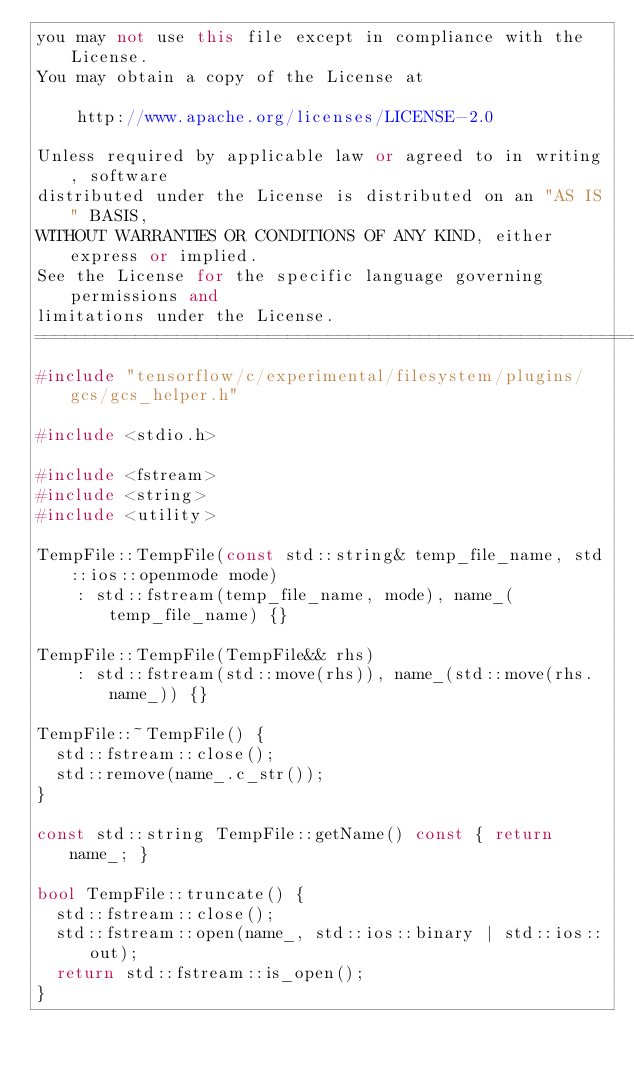Convert code to text. <code><loc_0><loc_0><loc_500><loc_500><_C++_>you may not use this file except in compliance with the License.
You may obtain a copy of the License at

    http://www.apache.org/licenses/LICENSE-2.0

Unless required by applicable law or agreed to in writing, software
distributed under the License is distributed on an "AS IS" BASIS,
WITHOUT WARRANTIES OR CONDITIONS OF ANY KIND, either express or implied.
See the License for the specific language governing permissions and
limitations under the License.
==============================================================================*/
#include "tensorflow/c/experimental/filesystem/plugins/gcs/gcs_helper.h"

#include <stdio.h>

#include <fstream>
#include <string>
#include <utility>

TempFile::TempFile(const std::string& temp_file_name, std::ios::openmode mode)
    : std::fstream(temp_file_name, mode), name_(temp_file_name) {}

TempFile::TempFile(TempFile&& rhs)
    : std::fstream(std::move(rhs)), name_(std::move(rhs.name_)) {}

TempFile::~TempFile() {
  std::fstream::close();
  std::remove(name_.c_str());
}

const std::string TempFile::getName() const { return name_; }

bool TempFile::truncate() {
  std::fstream::close();
  std::fstream::open(name_, std::ios::binary | std::ios::out);
  return std::fstream::is_open();
}
</code> 